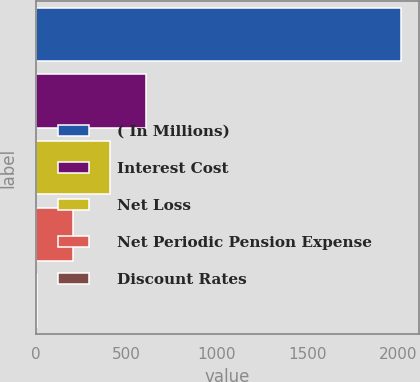Convert chart to OTSL. <chart><loc_0><loc_0><loc_500><loc_500><bar_chart><fcel>( In Millions)<fcel>Interest Cost<fcel>Net Loss<fcel>Net Periodic Pension Expense<fcel>Discount Rates<nl><fcel>2016<fcel>608.1<fcel>406.97<fcel>205.84<fcel>4.71<nl></chart> 